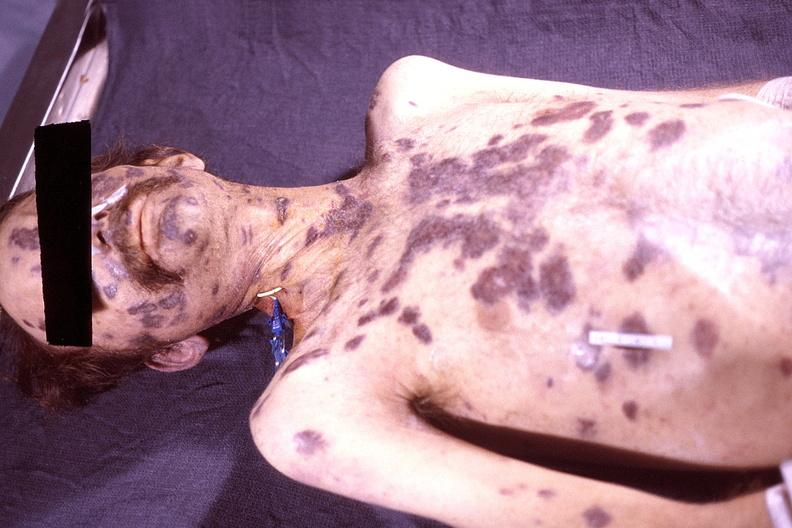where is this?
Answer the question using a single word or phrase. Skin 